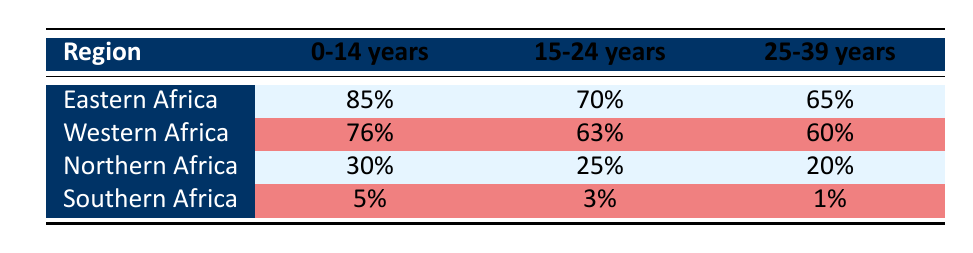What is the FGM prevalence percentage for girls aged 0-14 years in Eastern Africa? The table shows that in Eastern Africa, for the age group 0-14 years, the prevalence percentage is listed as 85%.
Answer: 85% Which region has the highest FGM prevalence percentage for the age group 15-24 years? By looking at the table, Eastern Africa has the highest prevalence percentage of 70% in the age group 15-24 years compared to other regions.
Answer: Eastern Africa What is the difference in FGM prevalence percentage between the age groups 0-14 years and 25-39 years in Western Africa? In Western Africa, the prevalence percentage for the age group 0-14 years is 76%, and for 25-39 years, it is 60%. The difference is calculated as 76% - 60% = 16%.
Answer: 16% Is the FGM prevalence percentage for the age group 25-39 years in Northern Africa higher than in Southern Africa? The table shows that Northern Africa has a prevalence percentage of 20% for the age group 25-39 years, while Southern Africa has only 1%. Therefore, it is true that Northern Africa has a higher percentage.
Answer: Yes What is the average FGM prevalence percentage for girls aged 15-24 years across all regions? To find the average for the age group 15-24 years, we add the percentages for all regions: 70% (Eastern Africa) + 63% (Western Africa) + 25% (Northern Africa) + 3% (Southern Africa) = 161%. There are four regions, so the average is 161%/4 = 40.25%.
Answer: 40.25% What is the FGM prevalence percentage for the age group 15-24 years in Southern Africa? The table states that in Southern Africa, the FGM prevalence percentage for the age group 15-24 years is 3%.
Answer: 3% Which region has the lowest prevalence for the age group 0-14 years? By checking the table, Southern Africa has the lowest prevalence percentage of 5% for the age group 0-14 years compared to other regions.
Answer: Southern Africa 